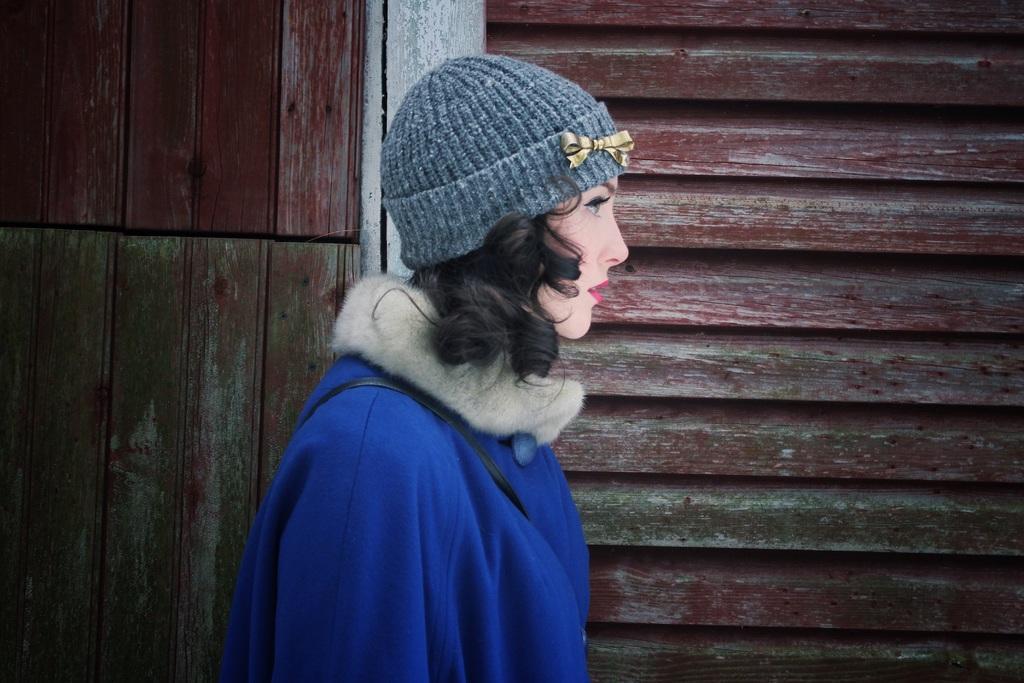Could you give a brief overview of what you see in this image? In this image we can see a woman wearing a blue color jacket and a gray color cap. There is a wooden wall on the backside. 